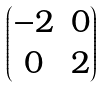Convert formula to latex. <formula><loc_0><loc_0><loc_500><loc_500>\begin{pmatrix} - 2 & 0 \\ 0 & 2 \end{pmatrix}</formula> 